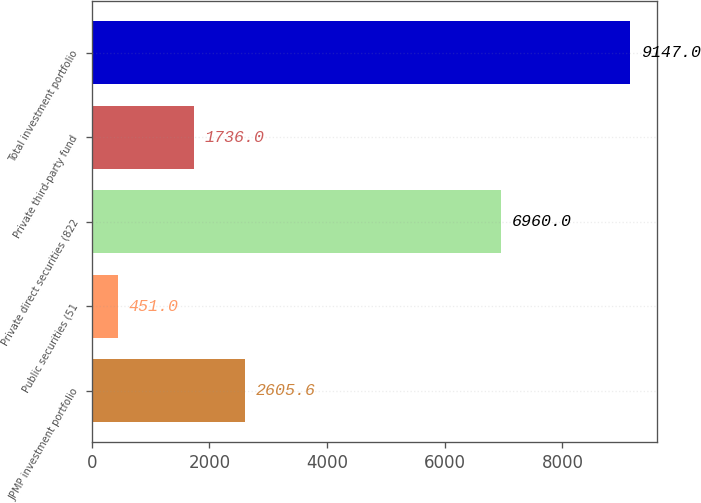Convert chart. <chart><loc_0><loc_0><loc_500><loc_500><bar_chart><fcel>JPMP investment portfolio<fcel>Public securities (51<fcel>Private direct securities (822<fcel>Private third-party fund<fcel>Total investment portfolio<nl><fcel>2605.6<fcel>451<fcel>6960<fcel>1736<fcel>9147<nl></chart> 